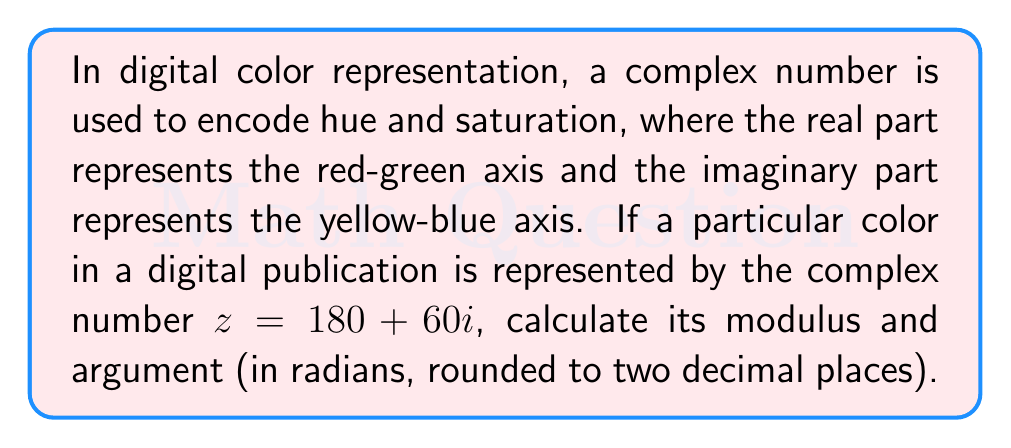Give your solution to this math problem. To find the modulus and argument of the complex number $z = 180 + 60i$, we'll follow these steps:

1. Calculate the modulus:
   The modulus of a complex number $z = a + bi$ is given by the formula:
   $$|z| = \sqrt{a^2 + b^2}$$
   In this case, $a = 180$ and $b = 60$:
   $$|z| = \sqrt{180^2 + 60^2} = \sqrt{32400 + 3600} = \sqrt{36000} = 60\sqrt{10} \approx 189.74$$

2. Calculate the argument:
   The argument of a complex number is given by the formula:
   $$\arg(z) = \tan^{-1}\left(\frac{b}{a}\right)$$
   However, we need to be careful about the quadrant. Since both $a$ and $b$ are positive, we're in the first quadrant, so we can use this formula directly:
   $$\arg(z) = \tan^{-1}\left(\frac{60}{180}\right) = \tan^{-1}\left(\frac{1}{3}\right) \approx 0.32 \text{ radians}$$

Therefore, the modulus is approximately 189.74, and the argument is approximately 0.32 radians.
Answer: Modulus: 189.74, Argument: 0.32 radians 